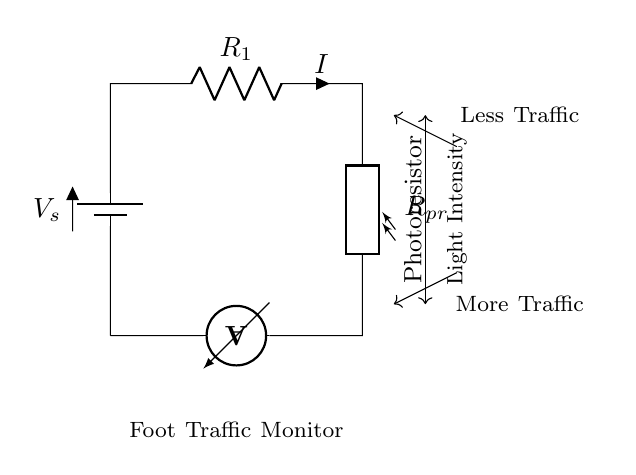What is the type of circuit depicted? The circuit is a series circuit, which can be identified by the arrangement of components connected end-to-end. This means that the same current flows through all components.
Answer: series circuit What does the photoresistor monitor? The photoresistor in the circuit monitors light intensity, as indicated by the label adjacent to the component and the arrows showing the relationship between light intensity and foot traffic.
Answer: light intensity What component measures current in this circuit? The ammeter is the component that measures the current flowing through the circuit. This can be identified by its position between the battery and the photoresistor, indicating it is in series with those components.
Answer: ammeter How does increased light intensity affect foot traffic? Increased light intensity is shown to correlate with less foot traffic in the diagram. This is explained by the arrows indicating that more light leads to a decrease in the amount of traffic monitored.
Answer: less traffic What is the symbol representing the power source? The symbol that represents the power source in the circuit is the battery. The text label specifies it as a voltage source with the designation "V_s."
Answer: battery What happens to current when foot traffic increases? When foot traffic increases, the light intensity decreases, leading to a change in resistance of the photoresistor, consequently increasing the current in the circuit. This is derived from the relationship of resistance, light intensity, and current in a series circuit.
Answer: increases 